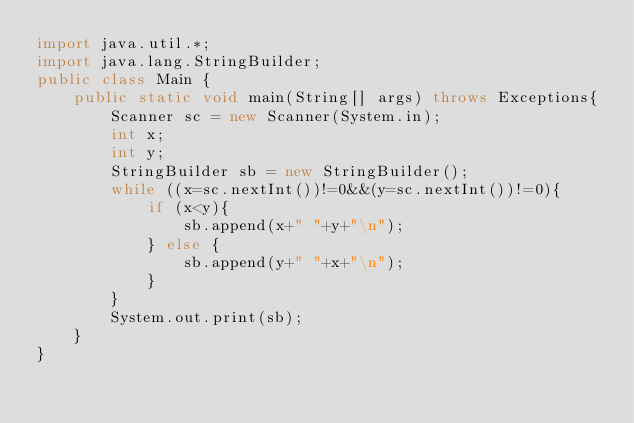<code> <loc_0><loc_0><loc_500><loc_500><_Java_>import java.util.*;
import java.lang.StringBuilder;
public class Main {
	public static void main(String[] args) throws Exceptions{
		Scanner sc = new Scanner(System.in);
		int x;
		int y;
		StringBuilder sb = new StringBuilder();
		while ((x=sc.nextInt())!=0&&(y=sc.nextInt())!=0){
			if (x<y){
				sb.append(x+" "+y+"\n");
			} else {
				sb.append(y+" "+x+"\n");
			}
		}
		System.out.print(sb);
	}
}</code> 